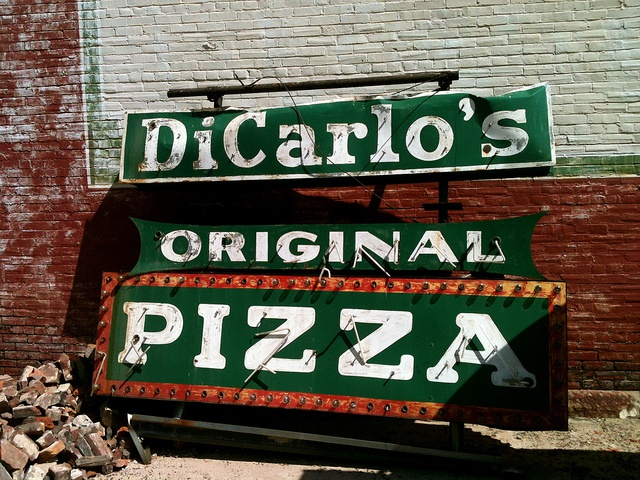Describe the objects in this image and their specific colors. I can see various objects in this image with different colors. 